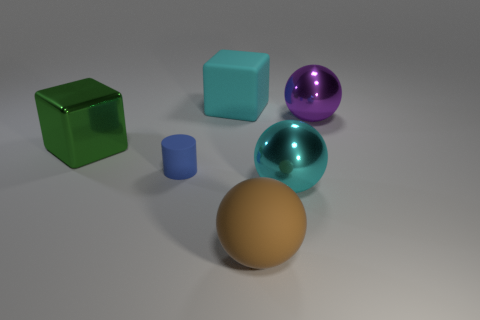Add 3 large blue balls. How many objects exist? 9 Subtract all cubes. How many objects are left? 4 Add 5 big cyan matte blocks. How many big cyan matte blocks are left? 6 Add 3 large things. How many large things exist? 8 Subtract 0 red cubes. How many objects are left? 6 Subtract all large green shiny blocks. Subtract all small rubber cylinders. How many objects are left? 4 